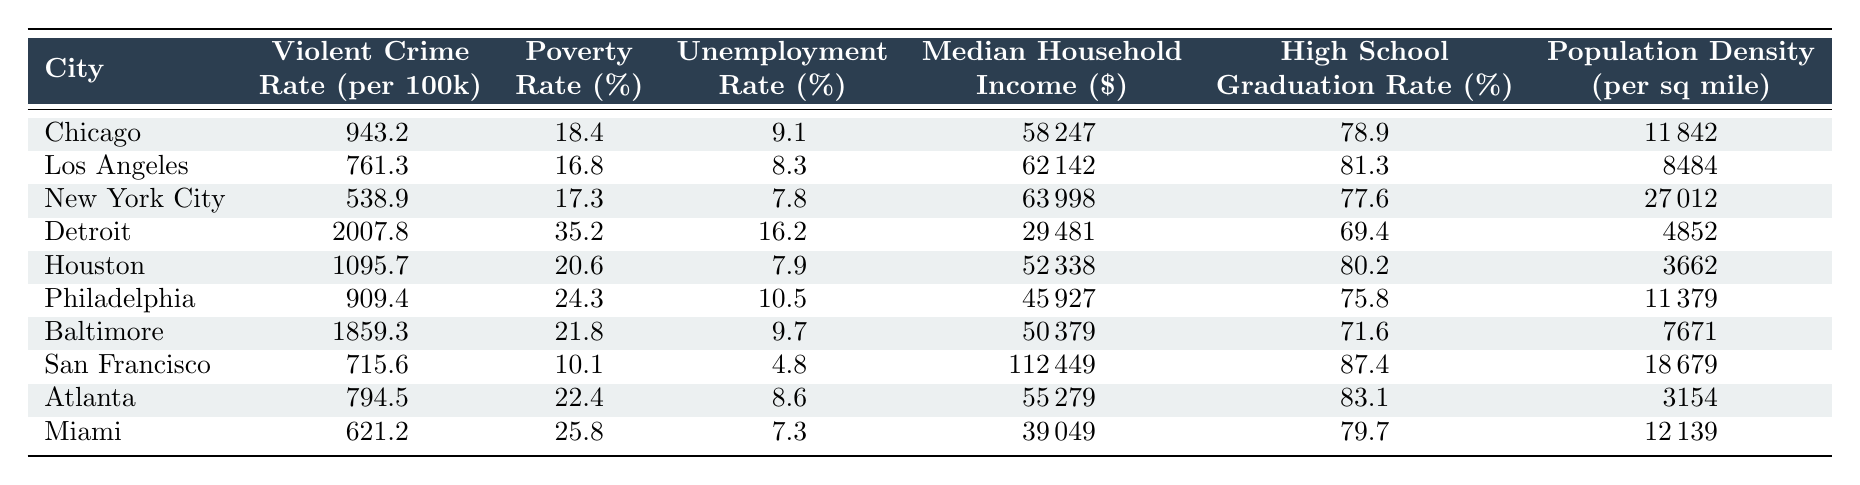What is the violent crime rate in Detroit? The table lists the violent crime rate for each city. For Detroit, it shows a rate of 2007.8 per 100,000 residents.
Answer: 2007.8 Which city has the highest poverty rate and what is it? By inspecting the "Poverty Rate (%)" column, Detroit has the highest value at 35.2%.
Answer: 35.2% What is the median household income of San Francisco? The table provides the median household income for San Francisco, which is listed as 112,449 dollars.
Answer: 112,449 What is the average violent crime rate for the cities listed in the table? To find the average, sum the violent crime rates: 943.2 + 761.3 + 538.9 + 2007.8 + 1095.7 + 909.4 + 1859.3 + 715.6 + 794.5 + 621.2 = 9,826.5. Then divide by the number of cities (10): 9826.5 / 10 = 982.65.
Answer: 982.65 Is the unemployment rate in Houston higher than that in Atlanta? Houston's unemployment rate is listed as 7.9%, while Atlanta's is 8.6%. Since 8.6% is greater than 7.9%, Houston's unemployment rate is not higher.
Answer: No How does the violent crime rate of Miami compare to that of Chicago? By comparing the violent crime rates, Miami's rate is 621.2 while Chicago's is 943.2. Therefore, Miami's rate is lower than Chicago's.
Answer: Lower What is the difference in high school graduation rates between Los Angeles and Detroit? Los Angeles has a high school graduation rate of 81.3%, and Detroit has 69.4%. The difference can be calculated as 81.3% - 69.4% = 11.9%.
Answer: 11.9 Can you identify which city has the highest population density? By examining the "Population Density (per sq mile)" column, New York City is identified with a density of 27,012 per square mile, which is the highest.
Answer: New York City If the poverty rate of Philadelphia were reduced by 10%, what would it be? Philadelphia's current poverty rate is 24.3%. Reducing it by 10% would result in 24.3% - (10% of 24.3) = 24.3% - 2.43% = 21.87%.
Answer: 21.87% Which cities have violent crime rates above 800 per 100,000? By reviewing the rates, Chicago (943.2), Detroit (2007.8), Houston (1095.7), Philadelphia (909.4), and Baltimore (1859.3) all exceed 800 per 100,000.
Answer: Chicago, Detroit, Houston, Philadelphia, Baltimore 